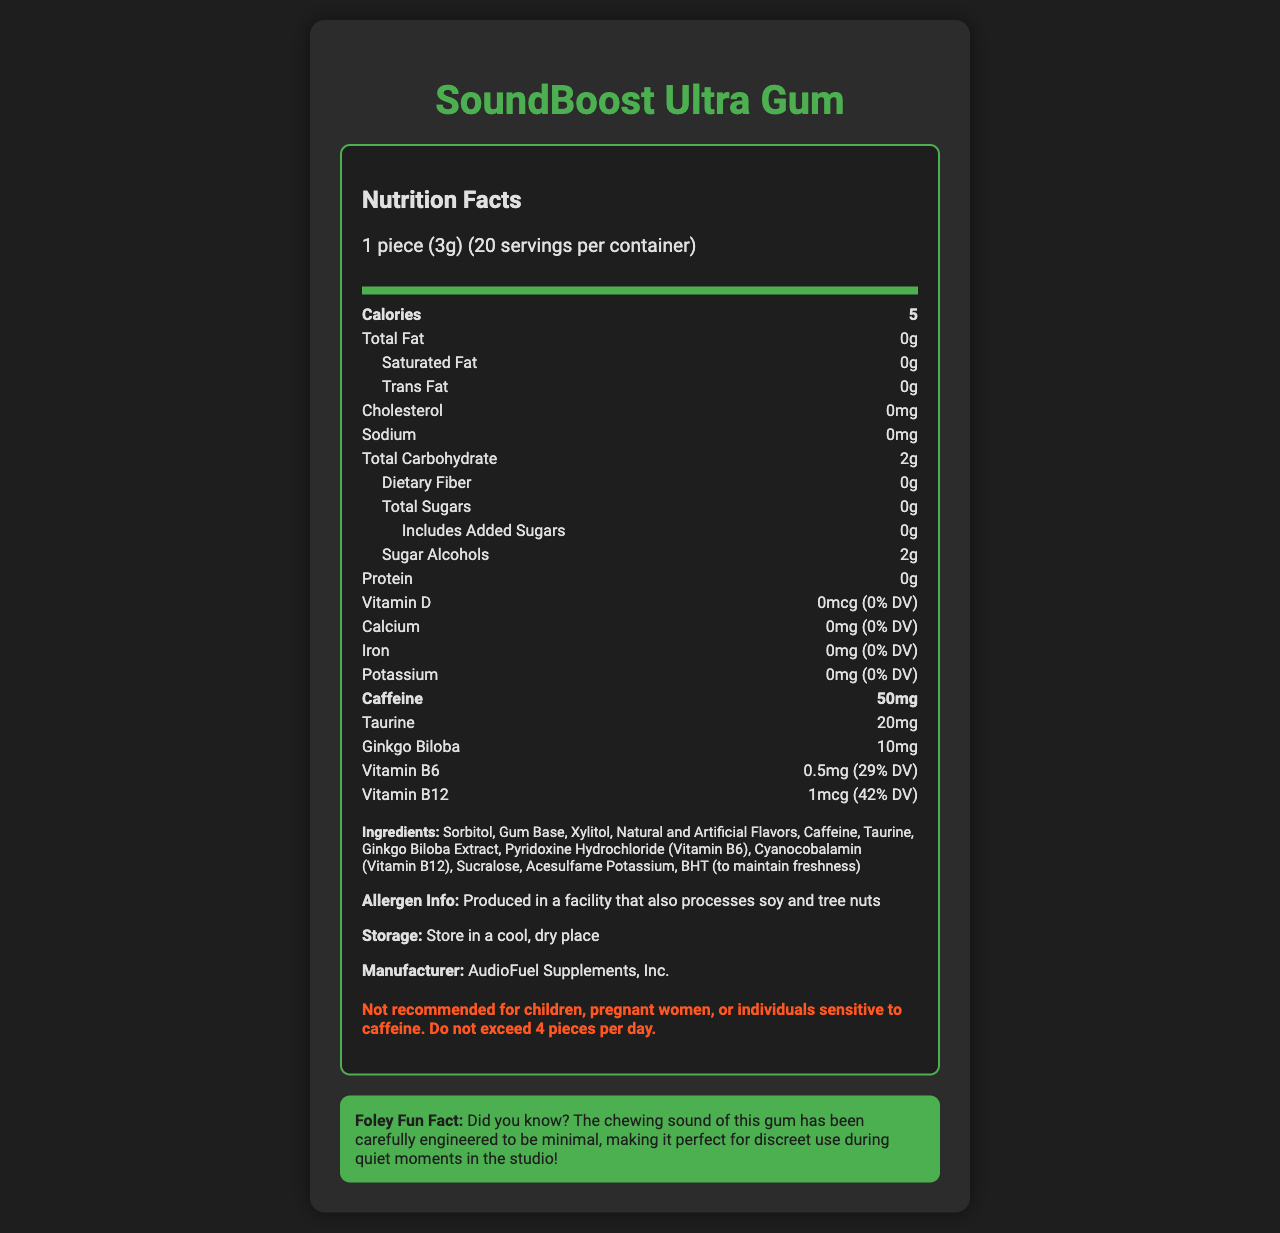What is the serving size of SoundBoost Ultra Gum? The serving size is clearly stated at the top of the nutrient section as "1 piece (3g)".
Answer: 1 piece (3g) How many servings are there per container? The information "20 servings per container" is listed right below the serving size.
Answer: 20 How many calories does one piece of SoundBoost Ultra Gum contain? "Calories" is listed and shows "5" calories per serving.
Answer: 5 What is the amount of caffeine per piece of gum? The caffeine content is mentioned in bold in the nutrient section as "50mg".
Answer: 50mg What is the amount of Vitamin B12 per piece of gum? The document mentions "Vitamin B12" as "1mcg (42% DV)" in the list of nutrients.
Answer: 1mcg (42% DV) Which ingredient helps maintain freshness? The ingredient list includes "BHT (to maintain freshness)".
Answer: BHT Where should the gum be stored? The storage instructions state "Store in a cool, dry place".
Answer: Store in a cool, dry place How much protein is in one piece of gum? Under the nutrient row, "Protein" is listed as "0g".
Answer: 0g What is the potassium content per piece? The potassium content is shown as "0mg (0% DV)".
Answer: 0mg (0% DV) What should be the maximum number of pieces consumed in a day? The document warns "Do not exceed 4 pieces per day".
Answer: 4 pieces Which manufacturer produces SoundBoost Ultra Gum? A. AudioFuel Lab B. AudioFuel Supplements, Inc. C. SoundEngineer Inc. The manufacturer is listed as "AudioFuel Supplements, Inc.".
Answer: B What is the percentage of daily value (% DV) for Vitamin B6? A. 10% B. 20% C. 29% D. 42% The nutrient "Vitamin B6" has "0.5mg (29% DV)" clearly listed.
Answer: C Is there any added sugar in SoundBoost Ultra Gum? The nutrient "Includes Added Sugars" is listed as "0g".
Answer: No Does the gum contain tree nuts or soy? The allergen information states "Produced in a facility that also processes soy and tree nuts."
Answer: Not specifically, but it is produced in a facility that processes soy and tree nuts Summarize the main purpose of SoundBoost Ultra Gum. The product description explains that it is tailored for sound engineers to help them stay alert and focused during extended recording and editing sessions and lists key energy-boosting ingredients.
Answer: SoundBoost Ultra Gum is designed for sound engineers and audio production professionals to maintain alertness and concentration during long working hours. It contains caffeine, taurine, ginkgo biloba, and B vitamins to help boost focus and energy. What is the nutritional benefit of ginkgo biloba in the gum? The document lists ginkgo biloba as an ingredient but does not explain its specific nutritional benefits.
Answer: Not enough information 